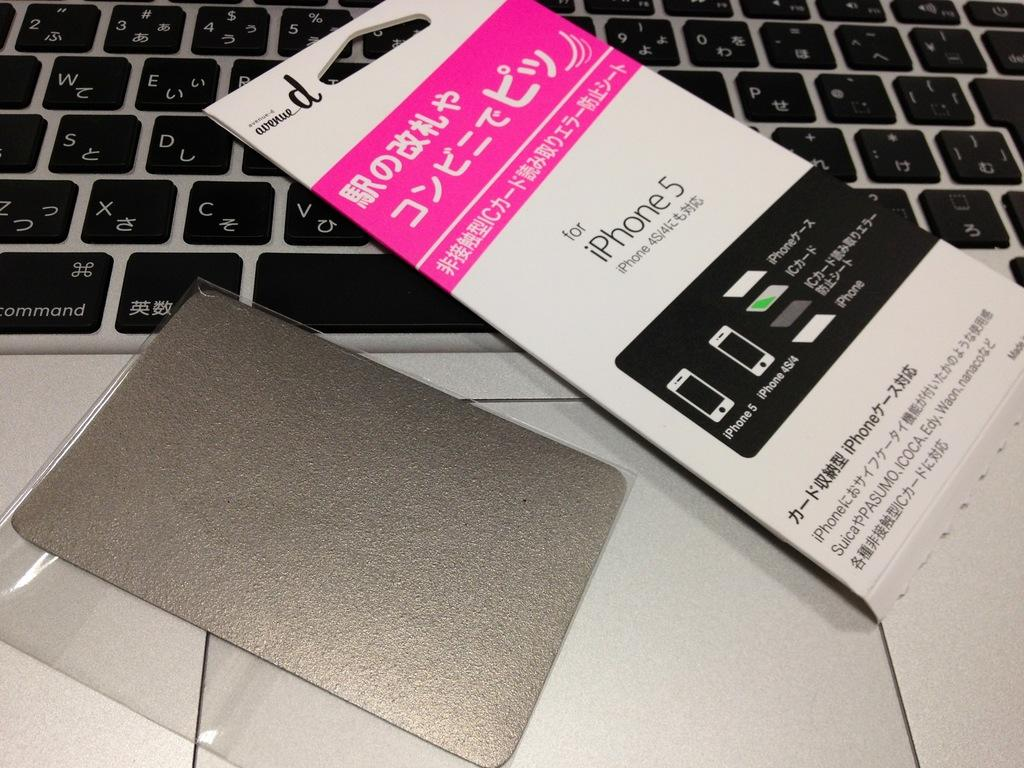Provide a one-sentence caption for the provided image. An iphone 5 screen protector in Japanese sitting on top of a Mac Book. 